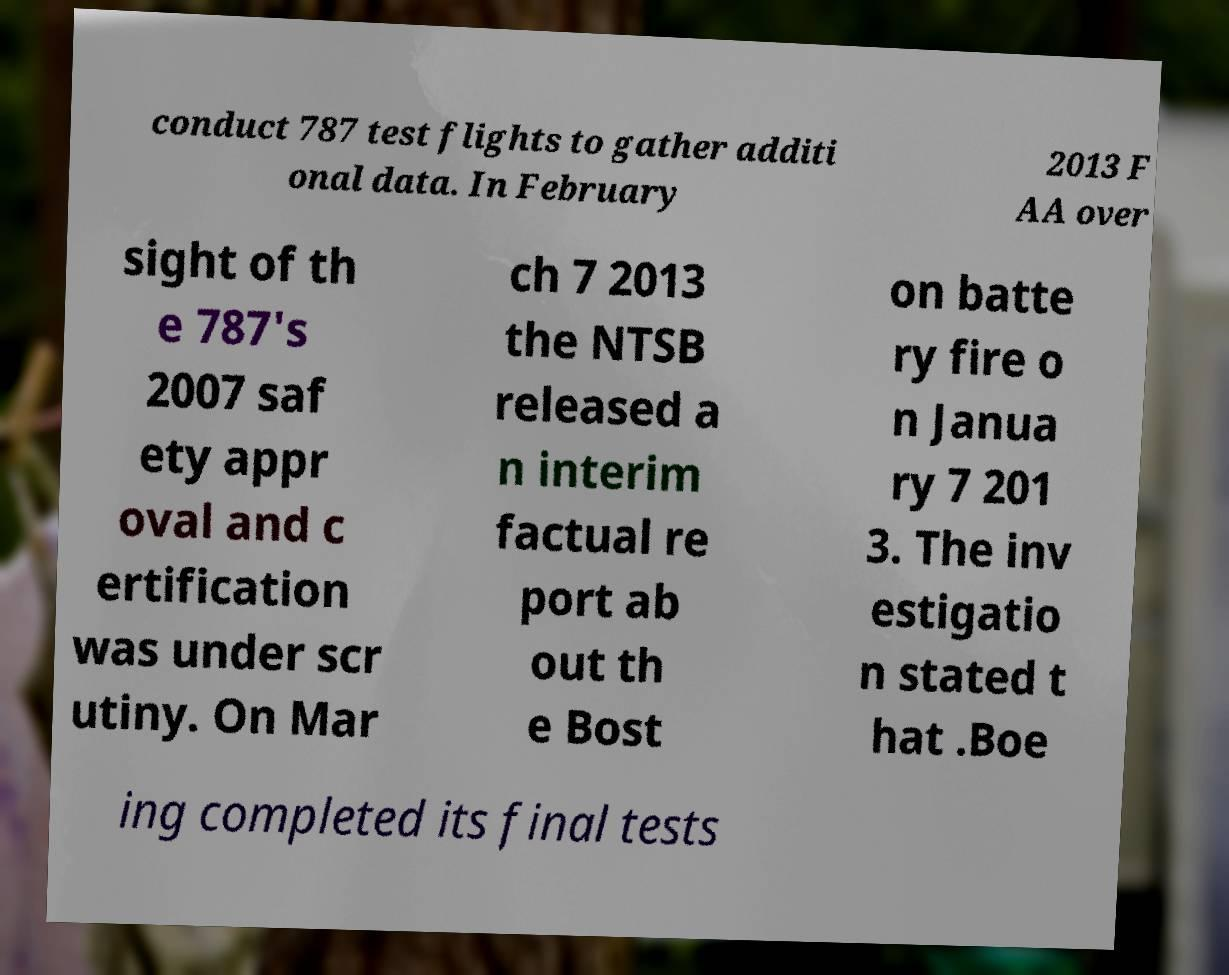What messages or text are displayed in this image? I need them in a readable, typed format. conduct 787 test flights to gather additi onal data. In February 2013 F AA over sight of th e 787's 2007 saf ety appr oval and c ertification was under scr utiny. On Mar ch 7 2013 the NTSB released a n interim factual re port ab out th e Bost on batte ry fire o n Janua ry 7 201 3. The inv estigatio n stated t hat .Boe ing completed its final tests 